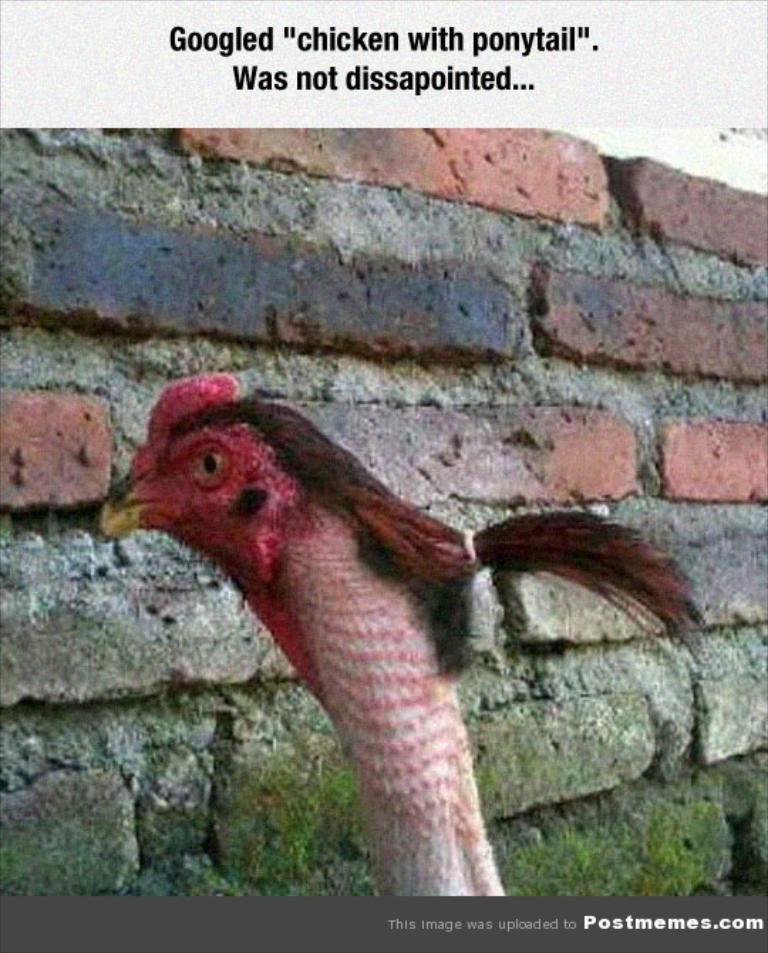What is the main subject of the image? The main subject of the image is a hen head. How are the hen's feathers arranged in the image? The hen's feathers are tied with a thread. What can be seen in the background of the image? There is a brick wall in the background of the image. Is there any text present in the image? Yes, text is written on the image, both at the top and bottom. Can you see the kitty playing with the cork in the image? There is no kitty or cork present in the image. 